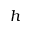<formula> <loc_0><loc_0><loc_500><loc_500>h</formula> 